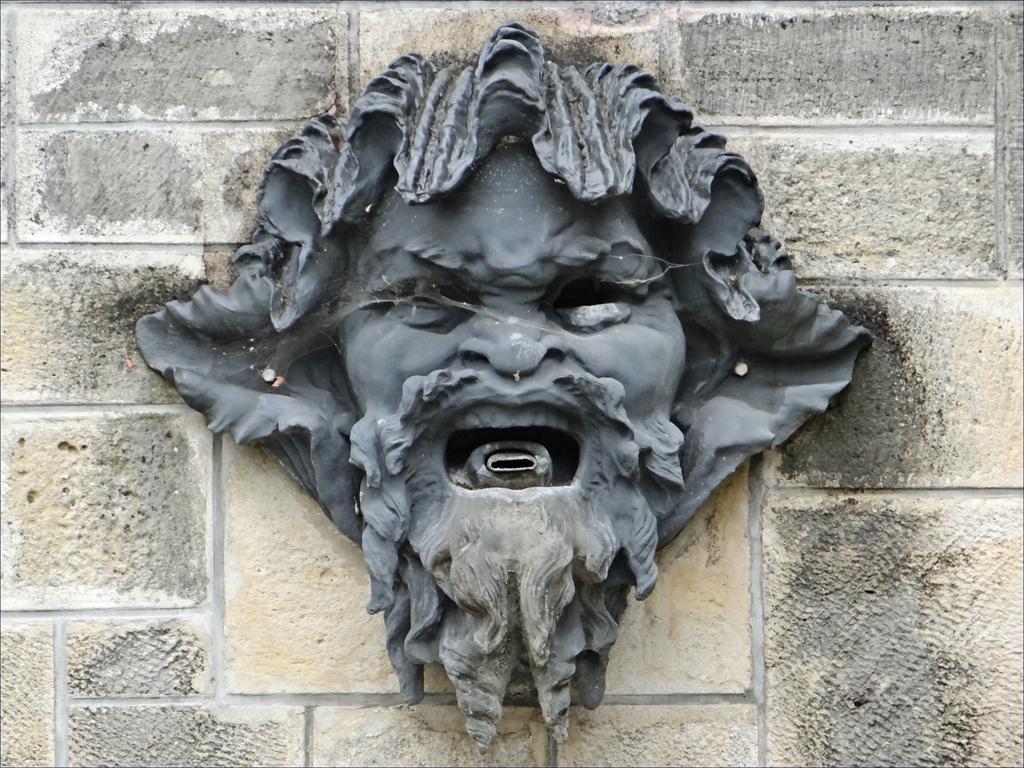Can you describe this image briefly? In this image we can see a statue on a wall. 